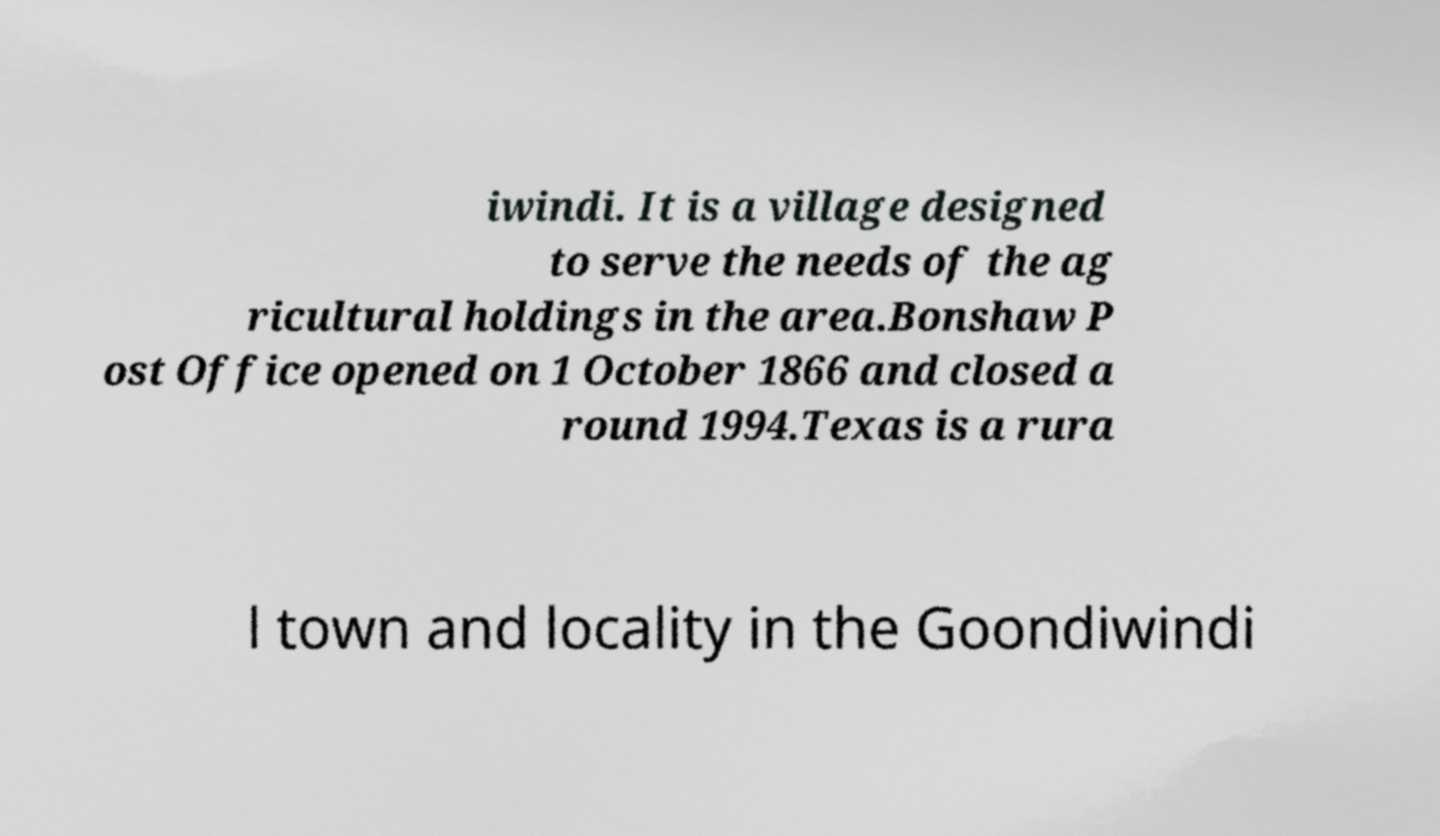Could you extract and type out the text from this image? iwindi. It is a village designed to serve the needs of the ag ricultural holdings in the area.Bonshaw P ost Office opened on 1 October 1866 and closed a round 1994.Texas is a rura l town and locality in the Goondiwindi 